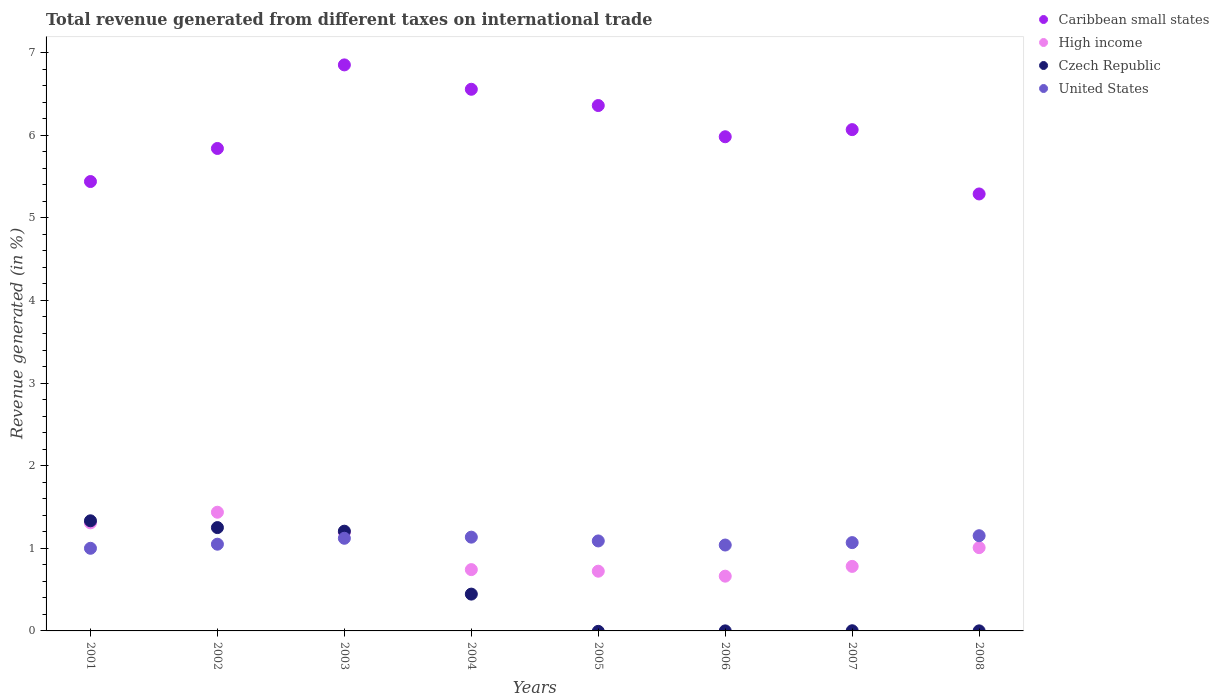Is the number of dotlines equal to the number of legend labels?
Keep it short and to the point. No. What is the total revenue generated in High income in 2004?
Your answer should be compact. 0.74. Across all years, what is the maximum total revenue generated in Caribbean small states?
Ensure brevity in your answer.  6.85. Across all years, what is the minimum total revenue generated in Caribbean small states?
Keep it short and to the point. 5.29. What is the total total revenue generated in High income in the graph?
Offer a very short reply. 7.85. What is the difference between the total revenue generated in United States in 2001 and that in 2005?
Provide a succinct answer. -0.09. What is the difference between the total revenue generated in High income in 2003 and the total revenue generated in United States in 2001?
Your answer should be very brief. 0.19. What is the average total revenue generated in Caribbean small states per year?
Your answer should be very brief. 6.05. In the year 2002, what is the difference between the total revenue generated in United States and total revenue generated in Caribbean small states?
Offer a terse response. -4.79. What is the ratio of the total revenue generated in Caribbean small states in 2001 to that in 2008?
Ensure brevity in your answer.  1.03. Is the difference between the total revenue generated in United States in 2003 and 2006 greater than the difference between the total revenue generated in Caribbean small states in 2003 and 2006?
Give a very brief answer. No. What is the difference between the highest and the second highest total revenue generated in Caribbean small states?
Provide a succinct answer. 0.3. What is the difference between the highest and the lowest total revenue generated in Caribbean small states?
Your response must be concise. 1.56. In how many years, is the total revenue generated in Caribbean small states greater than the average total revenue generated in Caribbean small states taken over all years?
Offer a very short reply. 4. Is the sum of the total revenue generated in United States in 2004 and 2007 greater than the maximum total revenue generated in Caribbean small states across all years?
Your answer should be compact. No. Is it the case that in every year, the sum of the total revenue generated in Caribbean small states and total revenue generated in Czech Republic  is greater than the total revenue generated in United States?
Give a very brief answer. Yes. Does the total revenue generated in Caribbean small states monotonically increase over the years?
Offer a terse response. No. How many years are there in the graph?
Your answer should be very brief. 8. What is the difference between two consecutive major ticks on the Y-axis?
Give a very brief answer. 1. Does the graph contain any zero values?
Offer a terse response. Yes. Does the graph contain grids?
Offer a terse response. No. How many legend labels are there?
Give a very brief answer. 4. What is the title of the graph?
Provide a succinct answer. Total revenue generated from different taxes on international trade. Does "Liberia" appear as one of the legend labels in the graph?
Provide a short and direct response. No. What is the label or title of the Y-axis?
Keep it short and to the point. Revenue generated (in %). What is the Revenue generated (in %) of Caribbean small states in 2001?
Ensure brevity in your answer.  5.44. What is the Revenue generated (in %) of High income in 2001?
Make the answer very short. 1.31. What is the Revenue generated (in %) of Czech Republic in 2001?
Your answer should be very brief. 1.33. What is the Revenue generated (in %) in United States in 2001?
Give a very brief answer. 1. What is the Revenue generated (in %) of Caribbean small states in 2002?
Make the answer very short. 5.84. What is the Revenue generated (in %) in High income in 2002?
Keep it short and to the point. 1.44. What is the Revenue generated (in %) of Czech Republic in 2002?
Keep it short and to the point. 1.25. What is the Revenue generated (in %) in United States in 2002?
Offer a terse response. 1.05. What is the Revenue generated (in %) of Caribbean small states in 2003?
Ensure brevity in your answer.  6.85. What is the Revenue generated (in %) in High income in 2003?
Your answer should be compact. 1.19. What is the Revenue generated (in %) of Czech Republic in 2003?
Give a very brief answer. 1.21. What is the Revenue generated (in %) of United States in 2003?
Provide a succinct answer. 1.12. What is the Revenue generated (in %) in Caribbean small states in 2004?
Your answer should be compact. 6.56. What is the Revenue generated (in %) of High income in 2004?
Give a very brief answer. 0.74. What is the Revenue generated (in %) of Czech Republic in 2004?
Offer a terse response. 0.45. What is the Revenue generated (in %) of United States in 2004?
Provide a succinct answer. 1.13. What is the Revenue generated (in %) of Caribbean small states in 2005?
Make the answer very short. 6.36. What is the Revenue generated (in %) in High income in 2005?
Offer a terse response. 0.72. What is the Revenue generated (in %) of Czech Republic in 2005?
Give a very brief answer. 0. What is the Revenue generated (in %) of United States in 2005?
Ensure brevity in your answer.  1.09. What is the Revenue generated (in %) of Caribbean small states in 2006?
Give a very brief answer. 5.98. What is the Revenue generated (in %) of High income in 2006?
Your response must be concise. 0.66. What is the Revenue generated (in %) in Czech Republic in 2006?
Keep it short and to the point. 0. What is the Revenue generated (in %) in United States in 2006?
Offer a very short reply. 1.04. What is the Revenue generated (in %) of Caribbean small states in 2007?
Offer a terse response. 6.07. What is the Revenue generated (in %) in High income in 2007?
Offer a terse response. 0.78. What is the Revenue generated (in %) in Czech Republic in 2007?
Make the answer very short. 0. What is the Revenue generated (in %) in United States in 2007?
Keep it short and to the point. 1.07. What is the Revenue generated (in %) of Caribbean small states in 2008?
Ensure brevity in your answer.  5.29. What is the Revenue generated (in %) of High income in 2008?
Your answer should be very brief. 1.01. What is the Revenue generated (in %) of Czech Republic in 2008?
Make the answer very short. 0. What is the Revenue generated (in %) of United States in 2008?
Make the answer very short. 1.15. Across all years, what is the maximum Revenue generated (in %) in Caribbean small states?
Your answer should be very brief. 6.85. Across all years, what is the maximum Revenue generated (in %) of High income?
Your answer should be compact. 1.44. Across all years, what is the maximum Revenue generated (in %) of Czech Republic?
Provide a short and direct response. 1.33. Across all years, what is the maximum Revenue generated (in %) in United States?
Your answer should be compact. 1.15. Across all years, what is the minimum Revenue generated (in %) in Caribbean small states?
Give a very brief answer. 5.29. Across all years, what is the minimum Revenue generated (in %) in High income?
Offer a terse response. 0.66. Across all years, what is the minimum Revenue generated (in %) in Czech Republic?
Keep it short and to the point. 0. Across all years, what is the minimum Revenue generated (in %) in United States?
Offer a very short reply. 1. What is the total Revenue generated (in %) of Caribbean small states in the graph?
Your answer should be compact. 48.38. What is the total Revenue generated (in %) in High income in the graph?
Your answer should be compact. 7.85. What is the total Revenue generated (in %) in Czech Republic in the graph?
Your answer should be very brief. 4.24. What is the total Revenue generated (in %) in United States in the graph?
Make the answer very short. 8.66. What is the difference between the Revenue generated (in %) of Caribbean small states in 2001 and that in 2002?
Keep it short and to the point. -0.4. What is the difference between the Revenue generated (in %) of High income in 2001 and that in 2002?
Keep it short and to the point. -0.13. What is the difference between the Revenue generated (in %) in Czech Republic in 2001 and that in 2002?
Your response must be concise. 0.08. What is the difference between the Revenue generated (in %) of United States in 2001 and that in 2002?
Provide a succinct answer. -0.05. What is the difference between the Revenue generated (in %) of Caribbean small states in 2001 and that in 2003?
Your answer should be very brief. -1.41. What is the difference between the Revenue generated (in %) of High income in 2001 and that in 2003?
Your answer should be very brief. 0.11. What is the difference between the Revenue generated (in %) of Czech Republic in 2001 and that in 2003?
Provide a succinct answer. 0.13. What is the difference between the Revenue generated (in %) of United States in 2001 and that in 2003?
Offer a very short reply. -0.12. What is the difference between the Revenue generated (in %) in Caribbean small states in 2001 and that in 2004?
Give a very brief answer. -1.12. What is the difference between the Revenue generated (in %) of High income in 2001 and that in 2004?
Give a very brief answer. 0.57. What is the difference between the Revenue generated (in %) of Czech Republic in 2001 and that in 2004?
Your answer should be compact. 0.89. What is the difference between the Revenue generated (in %) in United States in 2001 and that in 2004?
Your answer should be very brief. -0.13. What is the difference between the Revenue generated (in %) of Caribbean small states in 2001 and that in 2005?
Make the answer very short. -0.92. What is the difference between the Revenue generated (in %) in High income in 2001 and that in 2005?
Your answer should be compact. 0.58. What is the difference between the Revenue generated (in %) in United States in 2001 and that in 2005?
Your response must be concise. -0.09. What is the difference between the Revenue generated (in %) of Caribbean small states in 2001 and that in 2006?
Offer a terse response. -0.54. What is the difference between the Revenue generated (in %) of High income in 2001 and that in 2006?
Your answer should be compact. 0.65. What is the difference between the Revenue generated (in %) of Czech Republic in 2001 and that in 2006?
Keep it short and to the point. 1.33. What is the difference between the Revenue generated (in %) of United States in 2001 and that in 2006?
Provide a short and direct response. -0.04. What is the difference between the Revenue generated (in %) in Caribbean small states in 2001 and that in 2007?
Ensure brevity in your answer.  -0.63. What is the difference between the Revenue generated (in %) in High income in 2001 and that in 2007?
Your answer should be compact. 0.53. What is the difference between the Revenue generated (in %) of Czech Republic in 2001 and that in 2007?
Your answer should be compact. 1.33. What is the difference between the Revenue generated (in %) of United States in 2001 and that in 2007?
Your answer should be compact. -0.07. What is the difference between the Revenue generated (in %) of Caribbean small states in 2001 and that in 2008?
Offer a terse response. 0.15. What is the difference between the Revenue generated (in %) in High income in 2001 and that in 2008?
Ensure brevity in your answer.  0.3. What is the difference between the Revenue generated (in %) in Czech Republic in 2001 and that in 2008?
Make the answer very short. 1.33. What is the difference between the Revenue generated (in %) of United States in 2001 and that in 2008?
Your answer should be very brief. -0.15. What is the difference between the Revenue generated (in %) in Caribbean small states in 2002 and that in 2003?
Offer a very short reply. -1.01. What is the difference between the Revenue generated (in %) in High income in 2002 and that in 2003?
Make the answer very short. 0.24. What is the difference between the Revenue generated (in %) in Czech Republic in 2002 and that in 2003?
Provide a short and direct response. 0.04. What is the difference between the Revenue generated (in %) in United States in 2002 and that in 2003?
Give a very brief answer. -0.07. What is the difference between the Revenue generated (in %) in Caribbean small states in 2002 and that in 2004?
Give a very brief answer. -0.72. What is the difference between the Revenue generated (in %) of High income in 2002 and that in 2004?
Your response must be concise. 0.69. What is the difference between the Revenue generated (in %) in Czech Republic in 2002 and that in 2004?
Ensure brevity in your answer.  0.81. What is the difference between the Revenue generated (in %) in United States in 2002 and that in 2004?
Give a very brief answer. -0.09. What is the difference between the Revenue generated (in %) in Caribbean small states in 2002 and that in 2005?
Keep it short and to the point. -0.52. What is the difference between the Revenue generated (in %) in High income in 2002 and that in 2005?
Your answer should be very brief. 0.71. What is the difference between the Revenue generated (in %) of United States in 2002 and that in 2005?
Provide a succinct answer. -0.04. What is the difference between the Revenue generated (in %) in Caribbean small states in 2002 and that in 2006?
Ensure brevity in your answer.  -0.14. What is the difference between the Revenue generated (in %) in High income in 2002 and that in 2006?
Ensure brevity in your answer.  0.77. What is the difference between the Revenue generated (in %) of Czech Republic in 2002 and that in 2006?
Offer a very short reply. 1.25. What is the difference between the Revenue generated (in %) in United States in 2002 and that in 2006?
Your response must be concise. 0.01. What is the difference between the Revenue generated (in %) in Caribbean small states in 2002 and that in 2007?
Ensure brevity in your answer.  -0.23. What is the difference between the Revenue generated (in %) in High income in 2002 and that in 2007?
Make the answer very short. 0.66. What is the difference between the Revenue generated (in %) in Czech Republic in 2002 and that in 2007?
Your answer should be very brief. 1.25. What is the difference between the Revenue generated (in %) of United States in 2002 and that in 2007?
Give a very brief answer. -0.02. What is the difference between the Revenue generated (in %) in Caribbean small states in 2002 and that in 2008?
Your answer should be compact. 0.55. What is the difference between the Revenue generated (in %) of High income in 2002 and that in 2008?
Ensure brevity in your answer.  0.43. What is the difference between the Revenue generated (in %) in Czech Republic in 2002 and that in 2008?
Your answer should be very brief. 1.25. What is the difference between the Revenue generated (in %) in United States in 2002 and that in 2008?
Your answer should be very brief. -0.1. What is the difference between the Revenue generated (in %) of Caribbean small states in 2003 and that in 2004?
Offer a very short reply. 0.3. What is the difference between the Revenue generated (in %) in High income in 2003 and that in 2004?
Keep it short and to the point. 0.45. What is the difference between the Revenue generated (in %) in Czech Republic in 2003 and that in 2004?
Offer a terse response. 0.76. What is the difference between the Revenue generated (in %) in United States in 2003 and that in 2004?
Your answer should be very brief. -0.01. What is the difference between the Revenue generated (in %) of Caribbean small states in 2003 and that in 2005?
Your answer should be very brief. 0.49. What is the difference between the Revenue generated (in %) of High income in 2003 and that in 2005?
Provide a short and direct response. 0.47. What is the difference between the Revenue generated (in %) in United States in 2003 and that in 2005?
Give a very brief answer. 0.03. What is the difference between the Revenue generated (in %) in Caribbean small states in 2003 and that in 2006?
Your response must be concise. 0.87. What is the difference between the Revenue generated (in %) of High income in 2003 and that in 2006?
Provide a succinct answer. 0.53. What is the difference between the Revenue generated (in %) in Czech Republic in 2003 and that in 2006?
Your answer should be compact. 1.21. What is the difference between the Revenue generated (in %) in United States in 2003 and that in 2006?
Give a very brief answer. 0.08. What is the difference between the Revenue generated (in %) in Caribbean small states in 2003 and that in 2007?
Provide a succinct answer. 0.78. What is the difference between the Revenue generated (in %) in High income in 2003 and that in 2007?
Provide a short and direct response. 0.41. What is the difference between the Revenue generated (in %) of Czech Republic in 2003 and that in 2007?
Keep it short and to the point. 1.21. What is the difference between the Revenue generated (in %) in United States in 2003 and that in 2007?
Provide a succinct answer. 0.05. What is the difference between the Revenue generated (in %) in Caribbean small states in 2003 and that in 2008?
Offer a terse response. 1.56. What is the difference between the Revenue generated (in %) in High income in 2003 and that in 2008?
Provide a short and direct response. 0.19. What is the difference between the Revenue generated (in %) in Czech Republic in 2003 and that in 2008?
Make the answer very short. 1.21. What is the difference between the Revenue generated (in %) of United States in 2003 and that in 2008?
Give a very brief answer. -0.03. What is the difference between the Revenue generated (in %) in Caribbean small states in 2004 and that in 2005?
Offer a very short reply. 0.2. What is the difference between the Revenue generated (in %) in High income in 2004 and that in 2005?
Offer a terse response. 0.02. What is the difference between the Revenue generated (in %) of United States in 2004 and that in 2005?
Give a very brief answer. 0.05. What is the difference between the Revenue generated (in %) of Caribbean small states in 2004 and that in 2006?
Provide a succinct answer. 0.57. What is the difference between the Revenue generated (in %) of High income in 2004 and that in 2006?
Your response must be concise. 0.08. What is the difference between the Revenue generated (in %) of Czech Republic in 2004 and that in 2006?
Ensure brevity in your answer.  0.44. What is the difference between the Revenue generated (in %) in United States in 2004 and that in 2006?
Ensure brevity in your answer.  0.1. What is the difference between the Revenue generated (in %) in Caribbean small states in 2004 and that in 2007?
Keep it short and to the point. 0.49. What is the difference between the Revenue generated (in %) of High income in 2004 and that in 2007?
Provide a short and direct response. -0.04. What is the difference between the Revenue generated (in %) of Czech Republic in 2004 and that in 2007?
Your answer should be compact. 0.44. What is the difference between the Revenue generated (in %) of United States in 2004 and that in 2007?
Provide a short and direct response. 0.07. What is the difference between the Revenue generated (in %) of Caribbean small states in 2004 and that in 2008?
Give a very brief answer. 1.27. What is the difference between the Revenue generated (in %) in High income in 2004 and that in 2008?
Give a very brief answer. -0.27. What is the difference between the Revenue generated (in %) in Czech Republic in 2004 and that in 2008?
Make the answer very short. 0.44. What is the difference between the Revenue generated (in %) in United States in 2004 and that in 2008?
Provide a succinct answer. -0.02. What is the difference between the Revenue generated (in %) in Caribbean small states in 2005 and that in 2006?
Your response must be concise. 0.38. What is the difference between the Revenue generated (in %) in High income in 2005 and that in 2006?
Give a very brief answer. 0.06. What is the difference between the Revenue generated (in %) in United States in 2005 and that in 2006?
Offer a terse response. 0.05. What is the difference between the Revenue generated (in %) of Caribbean small states in 2005 and that in 2007?
Keep it short and to the point. 0.29. What is the difference between the Revenue generated (in %) in High income in 2005 and that in 2007?
Provide a short and direct response. -0.06. What is the difference between the Revenue generated (in %) in United States in 2005 and that in 2007?
Provide a short and direct response. 0.02. What is the difference between the Revenue generated (in %) of Caribbean small states in 2005 and that in 2008?
Your response must be concise. 1.07. What is the difference between the Revenue generated (in %) of High income in 2005 and that in 2008?
Your answer should be very brief. -0.29. What is the difference between the Revenue generated (in %) of United States in 2005 and that in 2008?
Provide a short and direct response. -0.06. What is the difference between the Revenue generated (in %) of Caribbean small states in 2006 and that in 2007?
Your response must be concise. -0.09. What is the difference between the Revenue generated (in %) of High income in 2006 and that in 2007?
Make the answer very short. -0.12. What is the difference between the Revenue generated (in %) of Czech Republic in 2006 and that in 2007?
Your response must be concise. -0. What is the difference between the Revenue generated (in %) in United States in 2006 and that in 2007?
Keep it short and to the point. -0.03. What is the difference between the Revenue generated (in %) in Caribbean small states in 2006 and that in 2008?
Give a very brief answer. 0.69. What is the difference between the Revenue generated (in %) in High income in 2006 and that in 2008?
Give a very brief answer. -0.35. What is the difference between the Revenue generated (in %) of Czech Republic in 2006 and that in 2008?
Ensure brevity in your answer.  -0. What is the difference between the Revenue generated (in %) in United States in 2006 and that in 2008?
Make the answer very short. -0.11. What is the difference between the Revenue generated (in %) in Caribbean small states in 2007 and that in 2008?
Your answer should be compact. 0.78. What is the difference between the Revenue generated (in %) in High income in 2007 and that in 2008?
Offer a terse response. -0.23. What is the difference between the Revenue generated (in %) in Czech Republic in 2007 and that in 2008?
Your response must be concise. 0. What is the difference between the Revenue generated (in %) in United States in 2007 and that in 2008?
Give a very brief answer. -0.08. What is the difference between the Revenue generated (in %) in Caribbean small states in 2001 and the Revenue generated (in %) in High income in 2002?
Provide a short and direct response. 4. What is the difference between the Revenue generated (in %) of Caribbean small states in 2001 and the Revenue generated (in %) of Czech Republic in 2002?
Your answer should be very brief. 4.19. What is the difference between the Revenue generated (in %) of Caribbean small states in 2001 and the Revenue generated (in %) of United States in 2002?
Give a very brief answer. 4.39. What is the difference between the Revenue generated (in %) in High income in 2001 and the Revenue generated (in %) in Czech Republic in 2002?
Your answer should be compact. 0.06. What is the difference between the Revenue generated (in %) in High income in 2001 and the Revenue generated (in %) in United States in 2002?
Keep it short and to the point. 0.26. What is the difference between the Revenue generated (in %) of Czech Republic in 2001 and the Revenue generated (in %) of United States in 2002?
Your answer should be compact. 0.28. What is the difference between the Revenue generated (in %) of Caribbean small states in 2001 and the Revenue generated (in %) of High income in 2003?
Provide a succinct answer. 4.25. What is the difference between the Revenue generated (in %) in Caribbean small states in 2001 and the Revenue generated (in %) in Czech Republic in 2003?
Your response must be concise. 4.23. What is the difference between the Revenue generated (in %) in Caribbean small states in 2001 and the Revenue generated (in %) in United States in 2003?
Give a very brief answer. 4.32. What is the difference between the Revenue generated (in %) in High income in 2001 and the Revenue generated (in %) in Czech Republic in 2003?
Keep it short and to the point. 0.1. What is the difference between the Revenue generated (in %) of High income in 2001 and the Revenue generated (in %) of United States in 2003?
Give a very brief answer. 0.19. What is the difference between the Revenue generated (in %) in Czech Republic in 2001 and the Revenue generated (in %) in United States in 2003?
Provide a short and direct response. 0.21. What is the difference between the Revenue generated (in %) of Caribbean small states in 2001 and the Revenue generated (in %) of High income in 2004?
Your response must be concise. 4.7. What is the difference between the Revenue generated (in %) in Caribbean small states in 2001 and the Revenue generated (in %) in Czech Republic in 2004?
Your response must be concise. 4.99. What is the difference between the Revenue generated (in %) of Caribbean small states in 2001 and the Revenue generated (in %) of United States in 2004?
Give a very brief answer. 4.3. What is the difference between the Revenue generated (in %) in High income in 2001 and the Revenue generated (in %) in Czech Republic in 2004?
Your answer should be compact. 0.86. What is the difference between the Revenue generated (in %) in High income in 2001 and the Revenue generated (in %) in United States in 2004?
Your answer should be very brief. 0.17. What is the difference between the Revenue generated (in %) of Czech Republic in 2001 and the Revenue generated (in %) of United States in 2004?
Offer a very short reply. 0.2. What is the difference between the Revenue generated (in %) of Caribbean small states in 2001 and the Revenue generated (in %) of High income in 2005?
Provide a succinct answer. 4.72. What is the difference between the Revenue generated (in %) in Caribbean small states in 2001 and the Revenue generated (in %) in United States in 2005?
Ensure brevity in your answer.  4.35. What is the difference between the Revenue generated (in %) of High income in 2001 and the Revenue generated (in %) of United States in 2005?
Keep it short and to the point. 0.22. What is the difference between the Revenue generated (in %) of Czech Republic in 2001 and the Revenue generated (in %) of United States in 2005?
Provide a short and direct response. 0.24. What is the difference between the Revenue generated (in %) of Caribbean small states in 2001 and the Revenue generated (in %) of High income in 2006?
Your answer should be very brief. 4.78. What is the difference between the Revenue generated (in %) in Caribbean small states in 2001 and the Revenue generated (in %) in Czech Republic in 2006?
Your answer should be very brief. 5.44. What is the difference between the Revenue generated (in %) of Caribbean small states in 2001 and the Revenue generated (in %) of United States in 2006?
Your response must be concise. 4.4. What is the difference between the Revenue generated (in %) of High income in 2001 and the Revenue generated (in %) of Czech Republic in 2006?
Your response must be concise. 1.31. What is the difference between the Revenue generated (in %) in High income in 2001 and the Revenue generated (in %) in United States in 2006?
Keep it short and to the point. 0.27. What is the difference between the Revenue generated (in %) in Czech Republic in 2001 and the Revenue generated (in %) in United States in 2006?
Provide a short and direct response. 0.29. What is the difference between the Revenue generated (in %) in Caribbean small states in 2001 and the Revenue generated (in %) in High income in 2007?
Make the answer very short. 4.66. What is the difference between the Revenue generated (in %) of Caribbean small states in 2001 and the Revenue generated (in %) of Czech Republic in 2007?
Keep it short and to the point. 5.44. What is the difference between the Revenue generated (in %) of Caribbean small states in 2001 and the Revenue generated (in %) of United States in 2007?
Offer a very short reply. 4.37. What is the difference between the Revenue generated (in %) of High income in 2001 and the Revenue generated (in %) of Czech Republic in 2007?
Provide a succinct answer. 1.31. What is the difference between the Revenue generated (in %) in High income in 2001 and the Revenue generated (in %) in United States in 2007?
Provide a succinct answer. 0.24. What is the difference between the Revenue generated (in %) of Czech Republic in 2001 and the Revenue generated (in %) of United States in 2007?
Make the answer very short. 0.26. What is the difference between the Revenue generated (in %) in Caribbean small states in 2001 and the Revenue generated (in %) in High income in 2008?
Offer a very short reply. 4.43. What is the difference between the Revenue generated (in %) of Caribbean small states in 2001 and the Revenue generated (in %) of Czech Republic in 2008?
Keep it short and to the point. 5.44. What is the difference between the Revenue generated (in %) of Caribbean small states in 2001 and the Revenue generated (in %) of United States in 2008?
Provide a short and direct response. 4.29. What is the difference between the Revenue generated (in %) of High income in 2001 and the Revenue generated (in %) of Czech Republic in 2008?
Keep it short and to the point. 1.31. What is the difference between the Revenue generated (in %) of High income in 2001 and the Revenue generated (in %) of United States in 2008?
Provide a succinct answer. 0.16. What is the difference between the Revenue generated (in %) in Czech Republic in 2001 and the Revenue generated (in %) in United States in 2008?
Provide a succinct answer. 0.18. What is the difference between the Revenue generated (in %) in Caribbean small states in 2002 and the Revenue generated (in %) in High income in 2003?
Your answer should be very brief. 4.65. What is the difference between the Revenue generated (in %) of Caribbean small states in 2002 and the Revenue generated (in %) of Czech Republic in 2003?
Make the answer very short. 4.63. What is the difference between the Revenue generated (in %) in Caribbean small states in 2002 and the Revenue generated (in %) in United States in 2003?
Keep it short and to the point. 4.72. What is the difference between the Revenue generated (in %) of High income in 2002 and the Revenue generated (in %) of Czech Republic in 2003?
Provide a short and direct response. 0.23. What is the difference between the Revenue generated (in %) in High income in 2002 and the Revenue generated (in %) in United States in 2003?
Your answer should be very brief. 0.32. What is the difference between the Revenue generated (in %) in Czech Republic in 2002 and the Revenue generated (in %) in United States in 2003?
Ensure brevity in your answer.  0.13. What is the difference between the Revenue generated (in %) of Caribbean small states in 2002 and the Revenue generated (in %) of High income in 2004?
Offer a very short reply. 5.1. What is the difference between the Revenue generated (in %) of Caribbean small states in 2002 and the Revenue generated (in %) of Czech Republic in 2004?
Give a very brief answer. 5.39. What is the difference between the Revenue generated (in %) in Caribbean small states in 2002 and the Revenue generated (in %) in United States in 2004?
Give a very brief answer. 4.7. What is the difference between the Revenue generated (in %) of High income in 2002 and the Revenue generated (in %) of Czech Republic in 2004?
Make the answer very short. 0.99. What is the difference between the Revenue generated (in %) of High income in 2002 and the Revenue generated (in %) of United States in 2004?
Provide a succinct answer. 0.3. What is the difference between the Revenue generated (in %) in Czech Republic in 2002 and the Revenue generated (in %) in United States in 2004?
Keep it short and to the point. 0.12. What is the difference between the Revenue generated (in %) of Caribbean small states in 2002 and the Revenue generated (in %) of High income in 2005?
Provide a short and direct response. 5.12. What is the difference between the Revenue generated (in %) of Caribbean small states in 2002 and the Revenue generated (in %) of United States in 2005?
Your answer should be very brief. 4.75. What is the difference between the Revenue generated (in %) in High income in 2002 and the Revenue generated (in %) in United States in 2005?
Keep it short and to the point. 0.35. What is the difference between the Revenue generated (in %) in Czech Republic in 2002 and the Revenue generated (in %) in United States in 2005?
Keep it short and to the point. 0.16. What is the difference between the Revenue generated (in %) of Caribbean small states in 2002 and the Revenue generated (in %) of High income in 2006?
Provide a short and direct response. 5.18. What is the difference between the Revenue generated (in %) of Caribbean small states in 2002 and the Revenue generated (in %) of Czech Republic in 2006?
Offer a very short reply. 5.84. What is the difference between the Revenue generated (in %) of Caribbean small states in 2002 and the Revenue generated (in %) of United States in 2006?
Ensure brevity in your answer.  4.8. What is the difference between the Revenue generated (in %) of High income in 2002 and the Revenue generated (in %) of Czech Republic in 2006?
Provide a short and direct response. 1.44. What is the difference between the Revenue generated (in %) in High income in 2002 and the Revenue generated (in %) in United States in 2006?
Give a very brief answer. 0.4. What is the difference between the Revenue generated (in %) in Czech Republic in 2002 and the Revenue generated (in %) in United States in 2006?
Your answer should be very brief. 0.21. What is the difference between the Revenue generated (in %) of Caribbean small states in 2002 and the Revenue generated (in %) of High income in 2007?
Ensure brevity in your answer.  5.06. What is the difference between the Revenue generated (in %) of Caribbean small states in 2002 and the Revenue generated (in %) of Czech Republic in 2007?
Your answer should be very brief. 5.84. What is the difference between the Revenue generated (in %) of Caribbean small states in 2002 and the Revenue generated (in %) of United States in 2007?
Keep it short and to the point. 4.77. What is the difference between the Revenue generated (in %) in High income in 2002 and the Revenue generated (in %) in Czech Republic in 2007?
Provide a succinct answer. 1.43. What is the difference between the Revenue generated (in %) in High income in 2002 and the Revenue generated (in %) in United States in 2007?
Ensure brevity in your answer.  0.37. What is the difference between the Revenue generated (in %) of Czech Republic in 2002 and the Revenue generated (in %) of United States in 2007?
Keep it short and to the point. 0.18. What is the difference between the Revenue generated (in %) of Caribbean small states in 2002 and the Revenue generated (in %) of High income in 2008?
Offer a terse response. 4.83. What is the difference between the Revenue generated (in %) in Caribbean small states in 2002 and the Revenue generated (in %) in Czech Republic in 2008?
Your answer should be very brief. 5.84. What is the difference between the Revenue generated (in %) in Caribbean small states in 2002 and the Revenue generated (in %) in United States in 2008?
Provide a short and direct response. 4.69. What is the difference between the Revenue generated (in %) of High income in 2002 and the Revenue generated (in %) of Czech Republic in 2008?
Your response must be concise. 1.44. What is the difference between the Revenue generated (in %) in High income in 2002 and the Revenue generated (in %) in United States in 2008?
Ensure brevity in your answer.  0.28. What is the difference between the Revenue generated (in %) in Czech Republic in 2002 and the Revenue generated (in %) in United States in 2008?
Your answer should be very brief. 0.1. What is the difference between the Revenue generated (in %) in Caribbean small states in 2003 and the Revenue generated (in %) in High income in 2004?
Your answer should be very brief. 6.11. What is the difference between the Revenue generated (in %) of Caribbean small states in 2003 and the Revenue generated (in %) of Czech Republic in 2004?
Offer a terse response. 6.41. What is the difference between the Revenue generated (in %) of Caribbean small states in 2003 and the Revenue generated (in %) of United States in 2004?
Provide a succinct answer. 5.72. What is the difference between the Revenue generated (in %) of High income in 2003 and the Revenue generated (in %) of Czech Republic in 2004?
Provide a short and direct response. 0.75. What is the difference between the Revenue generated (in %) of High income in 2003 and the Revenue generated (in %) of United States in 2004?
Offer a very short reply. 0.06. What is the difference between the Revenue generated (in %) of Czech Republic in 2003 and the Revenue generated (in %) of United States in 2004?
Provide a short and direct response. 0.07. What is the difference between the Revenue generated (in %) in Caribbean small states in 2003 and the Revenue generated (in %) in High income in 2005?
Provide a succinct answer. 6.13. What is the difference between the Revenue generated (in %) in Caribbean small states in 2003 and the Revenue generated (in %) in United States in 2005?
Your response must be concise. 5.76. What is the difference between the Revenue generated (in %) in High income in 2003 and the Revenue generated (in %) in United States in 2005?
Give a very brief answer. 0.1. What is the difference between the Revenue generated (in %) of Czech Republic in 2003 and the Revenue generated (in %) of United States in 2005?
Ensure brevity in your answer.  0.12. What is the difference between the Revenue generated (in %) in Caribbean small states in 2003 and the Revenue generated (in %) in High income in 2006?
Make the answer very short. 6.19. What is the difference between the Revenue generated (in %) in Caribbean small states in 2003 and the Revenue generated (in %) in Czech Republic in 2006?
Give a very brief answer. 6.85. What is the difference between the Revenue generated (in %) in Caribbean small states in 2003 and the Revenue generated (in %) in United States in 2006?
Offer a terse response. 5.81. What is the difference between the Revenue generated (in %) of High income in 2003 and the Revenue generated (in %) of Czech Republic in 2006?
Provide a short and direct response. 1.19. What is the difference between the Revenue generated (in %) in High income in 2003 and the Revenue generated (in %) in United States in 2006?
Your answer should be compact. 0.15. What is the difference between the Revenue generated (in %) of Czech Republic in 2003 and the Revenue generated (in %) of United States in 2006?
Keep it short and to the point. 0.17. What is the difference between the Revenue generated (in %) of Caribbean small states in 2003 and the Revenue generated (in %) of High income in 2007?
Your answer should be very brief. 6.07. What is the difference between the Revenue generated (in %) of Caribbean small states in 2003 and the Revenue generated (in %) of Czech Republic in 2007?
Offer a very short reply. 6.85. What is the difference between the Revenue generated (in %) of Caribbean small states in 2003 and the Revenue generated (in %) of United States in 2007?
Your response must be concise. 5.78. What is the difference between the Revenue generated (in %) of High income in 2003 and the Revenue generated (in %) of Czech Republic in 2007?
Your answer should be very brief. 1.19. What is the difference between the Revenue generated (in %) of High income in 2003 and the Revenue generated (in %) of United States in 2007?
Offer a very short reply. 0.12. What is the difference between the Revenue generated (in %) in Czech Republic in 2003 and the Revenue generated (in %) in United States in 2007?
Offer a terse response. 0.14. What is the difference between the Revenue generated (in %) of Caribbean small states in 2003 and the Revenue generated (in %) of High income in 2008?
Ensure brevity in your answer.  5.84. What is the difference between the Revenue generated (in %) in Caribbean small states in 2003 and the Revenue generated (in %) in Czech Republic in 2008?
Give a very brief answer. 6.85. What is the difference between the Revenue generated (in %) in Caribbean small states in 2003 and the Revenue generated (in %) in United States in 2008?
Give a very brief answer. 5.7. What is the difference between the Revenue generated (in %) of High income in 2003 and the Revenue generated (in %) of Czech Republic in 2008?
Your response must be concise. 1.19. What is the difference between the Revenue generated (in %) in High income in 2003 and the Revenue generated (in %) in United States in 2008?
Keep it short and to the point. 0.04. What is the difference between the Revenue generated (in %) of Czech Republic in 2003 and the Revenue generated (in %) of United States in 2008?
Provide a short and direct response. 0.05. What is the difference between the Revenue generated (in %) in Caribbean small states in 2004 and the Revenue generated (in %) in High income in 2005?
Offer a terse response. 5.83. What is the difference between the Revenue generated (in %) of Caribbean small states in 2004 and the Revenue generated (in %) of United States in 2005?
Provide a short and direct response. 5.47. What is the difference between the Revenue generated (in %) of High income in 2004 and the Revenue generated (in %) of United States in 2005?
Make the answer very short. -0.35. What is the difference between the Revenue generated (in %) of Czech Republic in 2004 and the Revenue generated (in %) of United States in 2005?
Give a very brief answer. -0.64. What is the difference between the Revenue generated (in %) of Caribbean small states in 2004 and the Revenue generated (in %) of High income in 2006?
Offer a terse response. 5.89. What is the difference between the Revenue generated (in %) in Caribbean small states in 2004 and the Revenue generated (in %) in Czech Republic in 2006?
Offer a terse response. 6.55. What is the difference between the Revenue generated (in %) of Caribbean small states in 2004 and the Revenue generated (in %) of United States in 2006?
Provide a succinct answer. 5.52. What is the difference between the Revenue generated (in %) in High income in 2004 and the Revenue generated (in %) in Czech Republic in 2006?
Keep it short and to the point. 0.74. What is the difference between the Revenue generated (in %) of High income in 2004 and the Revenue generated (in %) of United States in 2006?
Provide a succinct answer. -0.3. What is the difference between the Revenue generated (in %) of Czech Republic in 2004 and the Revenue generated (in %) of United States in 2006?
Offer a very short reply. -0.59. What is the difference between the Revenue generated (in %) of Caribbean small states in 2004 and the Revenue generated (in %) of High income in 2007?
Your answer should be very brief. 5.77. What is the difference between the Revenue generated (in %) of Caribbean small states in 2004 and the Revenue generated (in %) of Czech Republic in 2007?
Provide a short and direct response. 6.55. What is the difference between the Revenue generated (in %) in Caribbean small states in 2004 and the Revenue generated (in %) in United States in 2007?
Ensure brevity in your answer.  5.49. What is the difference between the Revenue generated (in %) in High income in 2004 and the Revenue generated (in %) in Czech Republic in 2007?
Provide a succinct answer. 0.74. What is the difference between the Revenue generated (in %) of High income in 2004 and the Revenue generated (in %) of United States in 2007?
Keep it short and to the point. -0.33. What is the difference between the Revenue generated (in %) in Czech Republic in 2004 and the Revenue generated (in %) in United States in 2007?
Give a very brief answer. -0.62. What is the difference between the Revenue generated (in %) in Caribbean small states in 2004 and the Revenue generated (in %) in High income in 2008?
Ensure brevity in your answer.  5.55. What is the difference between the Revenue generated (in %) in Caribbean small states in 2004 and the Revenue generated (in %) in Czech Republic in 2008?
Offer a terse response. 6.55. What is the difference between the Revenue generated (in %) of Caribbean small states in 2004 and the Revenue generated (in %) of United States in 2008?
Your response must be concise. 5.4. What is the difference between the Revenue generated (in %) of High income in 2004 and the Revenue generated (in %) of Czech Republic in 2008?
Offer a terse response. 0.74. What is the difference between the Revenue generated (in %) in High income in 2004 and the Revenue generated (in %) in United States in 2008?
Offer a very short reply. -0.41. What is the difference between the Revenue generated (in %) in Czech Republic in 2004 and the Revenue generated (in %) in United States in 2008?
Keep it short and to the point. -0.71. What is the difference between the Revenue generated (in %) in Caribbean small states in 2005 and the Revenue generated (in %) in High income in 2006?
Offer a terse response. 5.7. What is the difference between the Revenue generated (in %) in Caribbean small states in 2005 and the Revenue generated (in %) in Czech Republic in 2006?
Your response must be concise. 6.36. What is the difference between the Revenue generated (in %) in Caribbean small states in 2005 and the Revenue generated (in %) in United States in 2006?
Provide a succinct answer. 5.32. What is the difference between the Revenue generated (in %) in High income in 2005 and the Revenue generated (in %) in Czech Republic in 2006?
Your response must be concise. 0.72. What is the difference between the Revenue generated (in %) of High income in 2005 and the Revenue generated (in %) of United States in 2006?
Your response must be concise. -0.32. What is the difference between the Revenue generated (in %) of Caribbean small states in 2005 and the Revenue generated (in %) of High income in 2007?
Ensure brevity in your answer.  5.58. What is the difference between the Revenue generated (in %) in Caribbean small states in 2005 and the Revenue generated (in %) in Czech Republic in 2007?
Your answer should be very brief. 6.36. What is the difference between the Revenue generated (in %) in Caribbean small states in 2005 and the Revenue generated (in %) in United States in 2007?
Provide a succinct answer. 5.29. What is the difference between the Revenue generated (in %) of High income in 2005 and the Revenue generated (in %) of Czech Republic in 2007?
Provide a short and direct response. 0.72. What is the difference between the Revenue generated (in %) in High income in 2005 and the Revenue generated (in %) in United States in 2007?
Provide a succinct answer. -0.35. What is the difference between the Revenue generated (in %) of Caribbean small states in 2005 and the Revenue generated (in %) of High income in 2008?
Your answer should be very brief. 5.35. What is the difference between the Revenue generated (in %) of Caribbean small states in 2005 and the Revenue generated (in %) of Czech Republic in 2008?
Your response must be concise. 6.36. What is the difference between the Revenue generated (in %) in Caribbean small states in 2005 and the Revenue generated (in %) in United States in 2008?
Provide a short and direct response. 5.21. What is the difference between the Revenue generated (in %) in High income in 2005 and the Revenue generated (in %) in Czech Republic in 2008?
Provide a short and direct response. 0.72. What is the difference between the Revenue generated (in %) of High income in 2005 and the Revenue generated (in %) of United States in 2008?
Offer a terse response. -0.43. What is the difference between the Revenue generated (in %) in Caribbean small states in 2006 and the Revenue generated (in %) in High income in 2007?
Offer a terse response. 5.2. What is the difference between the Revenue generated (in %) in Caribbean small states in 2006 and the Revenue generated (in %) in Czech Republic in 2007?
Provide a short and direct response. 5.98. What is the difference between the Revenue generated (in %) in Caribbean small states in 2006 and the Revenue generated (in %) in United States in 2007?
Your answer should be compact. 4.91. What is the difference between the Revenue generated (in %) in High income in 2006 and the Revenue generated (in %) in Czech Republic in 2007?
Provide a succinct answer. 0.66. What is the difference between the Revenue generated (in %) of High income in 2006 and the Revenue generated (in %) of United States in 2007?
Give a very brief answer. -0.41. What is the difference between the Revenue generated (in %) in Czech Republic in 2006 and the Revenue generated (in %) in United States in 2007?
Keep it short and to the point. -1.07. What is the difference between the Revenue generated (in %) in Caribbean small states in 2006 and the Revenue generated (in %) in High income in 2008?
Offer a very short reply. 4.97. What is the difference between the Revenue generated (in %) in Caribbean small states in 2006 and the Revenue generated (in %) in Czech Republic in 2008?
Your response must be concise. 5.98. What is the difference between the Revenue generated (in %) in Caribbean small states in 2006 and the Revenue generated (in %) in United States in 2008?
Keep it short and to the point. 4.83. What is the difference between the Revenue generated (in %) in High income in 2006 and the Revenue generated (in %) in Czech Republic in 2008?
Ensure brevity in your answer.  0.66. What is the difference between the Revenue generated (in %) in High income in 2006 and the Revenue generated (in %) in United States in 2008?
Your answer should be very brief. -0.49. What is the difference between the Revenue generated (in %) in Czech Republic in 2006 and the Revenue generated (in %) in United States in 2008?
Your answer should be very brief. -1.15. What is the difference between the Revenue generated (in %) in Caribbean small states in 2007 and the Revenue generated (in %) in High income in 2008?
Provide a short and direct response. 5.06. What is the difference between the Revenue generated (in %) of Caribbean small states in 2007 and the Revenue generated (in %) of Czech Republic in 2008?
Offer a terse response. 6.07. What is the difference between the Revenue generated (in %) of Caribbean small states in 2007 and the Revenue generated (in %) of United States in 2008?
Your answer should be compact. 4.92. What is the difference between the Revenue generated (in %) of High income in 2007 and the Revenue generated (in %) of Czech Republic in 2008?
Your answer should be very brief. 0.78. What is the difference between the Revenue generated (in %) of High income in 2007 and the Revenue generated (in %) of United States in 2008?
Make the answer very short. -0.37. What is the difference between the Revenue generated (in %) of Czech Republic in 2007 and the Revenue generated (in %) of United States in 2008?
Offer a very short reply. -1.15. What is the average Revenue generated (in %) of Caribbean small states per year?
Provide a short and direct response. 6.05. What is the average Revenue generated (in %) in High income per year?
Make the answer very short. 0.98. What is the average Revenue generated (in %) in Czech Republic per year?
Your answer should be compact. 0.53. What is the average Revenue generated (in %) of United States per year?
Offer a very short reply. 1.08. In the year 2001, what is the difference between the Revenue generated (in %) of Caribbean small states and Revenue generated (in %) of High income?
Your answer should be very brief. 4.13. In the year 2001, what is the difference between the Revenue generated (in %) in Caribbean small states and Revenue generated (in %) in Czech Republic?
Provide a short and direct response. 4.11. In the year 2001, what is the difference between the Revenue generated (in %) in Caribbean small states and Revenue generated (in %) in United States?
Provide a succinct answer. 4.44. In the year 2001, what is the difference between the Revenue generated (in %) of High income and Revenue generated (in %) of Czech Republic?
Offer a very short reply. -0.02. In the year 2001, what is the difference between the Revenue generated (in %) in High income and Revenue generated (in %) in United States?
Ensure brevity in your answer.  0.31. In the year 2001, what is the difference between the Revenue generated (in %) in Czech Republic and Revenue generated (in %) in United States?
Make the answer very short. 0.33. In the year 2002, what is the difference between the Revenue generated (in %) in Caribbean small states and Revenue generated (in %) in High income?
Keep it short and to the point. 4.4. In the year 2002, what is the difference between the Revenue generated (in %) in Caribbean small states and Revenue generated (in %) in Czech Republic?
Give a very brief answer. 4.59. In the year 2002, what is the difference between the Revenue generated (in %) of Caribbean small states and Revenue generated (in %) of United States?
Give a very brief answer. 4.79. In the year 2002, what is the difference between the Revenue generated (in %) of High income and Revenue generated (in %) of Czech Republic?
Provide a succinct answer. 0.19. In the year 2002, what is the difference between the Revenue generated (in %) in High income and Revenue generated (in %) in United States?
Your answer should be compact. 0.39. In the year 2002, what is the difference between the Revenue generated (in %) of Czech Republic and Revenue generated (in %) of United States?
Offer a terse response. 0.2. In the year 2003, what is the difference between the Revenue generated (in %) in Caribbean small states and Revenue generated (in %) in High income?
Provide a short and direct response. 5.66. In the year 2003, what is the difference between the Revenue generated (in %) in Caribbean small states and Revenue generated (in %) in Czech Republic?
Your response must be concise. 5.64. In the year 2003, what is the difference between the Revenue generated (in %) in Caribbean small states and Revenue generated (in %) in United States?
Offer a terse response. 5.73. In the year 2003, what is the difference between the Revenue generated (in %) in High income and Revenue generated (in %) in Czech Republic?
Provide a succinct answer. -0.01. In the year 2003, what is the difference between the Revenue generated (in %) of High income and Revenue generated (in %) of United States?
Keep it short and to the point. 0.07. In the year 2003, what is the difference between the Revenue generated (in %) in Czech Republic and Revenue generated (in %) in United States?
Provide a succinct answer. 0.09. In the year 2004, what is the difference between the Revenue generated (in %) of Caribbean small states and Revenue generated (in %) of High income?
Your answer should be very brief. 5.81. In the year 2004, what is the difference between the Revenue generated (in %) in Caribbean small states and Revenue generated (in %) in Czech Republic?
Offer a terse response. 6.11. In the year 2004, what is the difference between the Revenue generated (in %) of Caribbean small states and Revenue generated (in %) of United States?
Offer a terse response. 5.42. In the year 2004, what is the difference between the Revenue generated (in %) of High income and Revenue generated (in %) of Czech Republic?
Keep it short and to the point. 0.3. In the year 2004, what is the difference between the Revenue generated (in %) in High income and Revenue generated (in %) in United States?
Offer a very short reply. -0.39. In the year 2004, what is the difference between the Revenue generated (in %) in Czech Republic and Revenue generated (in %) in United States?
Ensure brevity in your answer.  -0.69. In the year 2005, what is the difference between the Revenue generated (in %) of Caribbean small states and Revenue generated (in %) of High income?
Ensure brevity in your answer.  5.64. In the year 2005, what is the difference between the Revenue generated (in %) of Caribbean small states and Revenue generated (in %) of United States?
Offer a terse response. 5.27. In the year 2005, what is the difference between the Revenue generated (in %) of High income and Revenue generated (in %) of United States?
Ensure brevity in your answer.  -0.37. In the year 2006, what is the difference between the Revenue generated (in %) in Caribbean small states and Revenue generated (in %) in High income?
Offer a very short reply. 5.32. In the year 2006, what is the difference between the Revenue generated (in %) in Caribbean small states and Revenue generated (in %) in Czech Republic?
Offer a very short reply. 5.98. In the year 2006, what is the difference between the Revenue generated (in %) of Caribbean small states and Revenue generated (in %) of United States?
Provide a short and direct response. 4.94. In the year 2006, what is the difference between the Revenue generated (in %) in High income and Revenue generated (in %) in Czech Republic?
Give a very brief answer. 0.66. In the year 2006, what is the difference between the Revenue generated (in %) in High income and Revenue generated (in %) in United States?
Make the answer very short. -0.38. In the year 2006, what is the difference between the Revenue generated (in %) in Czech Republic and Revenue generated (in %) in United States?
Your answer should be very brief. -1.04. In the year 2007, what is the difference between the Revenue generated (in %) of Caribbean small states and Revenue generated (in %) of High income?
Offer a terse response. 5.29. In the year 2007, what is the difference between the Revenue generated (in %) in Caribbean small states and Revenue generated (in %) in Czech Republic?
Offer a terse response. 6.07. In the year 2007, what is the difference between the Revenue generated (in %) of Caribbean small states and Revenue generated (in %) of United States?
Provide a short and direct response. 5. In the year 2007, what is the difference between the Revenue generated (in %) in High income and Revenue generated (in %) in Czech Republic?
Provide a short and direct response. 0.78. In the year 2007, what is the difference between the Revenue generated (in %) in High income and Revenue generated (in %) in United States?
Offer a terse response. -0.29. In the year 2007, what is the difference between the Revenue generated (in %) of Czech Republic and Revenue generated (in %) of United States?
Provide a succinct answer. -1.07. In the year 2008, what is the difference between the Revenue generated (in %) in Caribbean small states and Revenue generated (in %) in High income?
Your answer should be compact. 4.28. In the year 2008, what is the difference between the Revenue generated (in %) of Caribbean small states and Revenue generated (in %) of Czech Republic?
Provide a short and direct response. 5.29. In the year 2008, what is the difference between the Revenue generated (in %) in Caribbean small states and Revenue generated (in %) in United States?
Make the answer very short. 4.14. In the year 2008, what is the difference between the Revenue generated (in %) of High income and Revenue generated (in %) of Czech Republic?
Your answer should be very brief. 1.01. In the year 2008, what is the difference between the Revenue generated (in %) in High income and Revenue generated (in %) in United States?
Keep it short and to the point. -0.14. In the year 2008, what is the difference between the Revenue generated (in %) of Czech Republic and Revenue generated (in %) of United States?
Your answer should be compact. -1.15. What is the ratio of the Revenue generated (in %) of Caribbean small states in 2001 to that in 2002?
Your response must be concise. 0.93. What is the ratio of the Revenue generated (in %) of High income in 2001 to that in 2002?
Make the answer very short. 0.91. What is the ratio of the Revenue generated (in %) of Czech Republic in 2001 to that in 2002?
Give a very brief answer. 1.07. What is the ratio of the Revenue generated (in %) in United States in 2001 to that in 2002?
Your answer should be compact. 0.95. What is the ratio of the Revenue generated (in %) in Caribbean small states in 2001 to that in 2003?
Offer a very short reply. 0.79. What is the ratio of the Revenue generated (in %) in High income in 2001 to that in 2003?
Your answer should be very brief. 1.1. What is the ratio of the Revenue generated (in %) in Czech Republic in 2001 to that in 2003?
Your response must be concise. 1.1. What is the ratio of the Revenue generated (in %) of United States in 2001 to that in 2003?
Keep it short and to the point. 0.89. What is the ratio of the Revenue generated (in %) in Caribbean small states in 2001 to that in 2004?
Offer a terse response. 0.83. What is the ratio of the Revenue generated (in %) in High income in 2001 to that in 2004?
Provide a short and direct response. 1.76. What is the ratio of the Revenue generated (in %) in Czech Republic in 2001 to that in 2004?
Offer a very short reply. 2.99. What is the ratio of the Revenue generated (in %) of United States in 2001 to that in 2004?
Provide a succinct answer. 0.88. What is the ratio of the Revenue generated (in %) of Caribbean small states in 2001 to that in 2005?
Give a very brief answer. 0.86. What is the ratio of the Revenue generated (in %) of High income in 2001 to that in 2005?
Make the answer very short. 1.81. What is the ratio of the Revenue generated (in %) of United States in 2001 to that in 2005?
Ensure brevity in your answer.  0.92. What is the ratio of the Revenue generated (in %) in Caribbean small states in 2001 to that in 2006?
Offer a terse response. 0.91. What is the ratio of the Revenue generated (in %) in High income in 2001 to that in 2006?
Ensure brevity in your answer.  1.97. What is the ratio of the Revenue generated (in %) of Czech Republic in 2001 to that in 2006?
Provide a short and direct response. 2283.11. What is the ratio of the Revenue generated (in %) in United States in 2001 to that in 2006?
Your response must be concise. 0.96. What is the ratio of the Revenue generated (in %) of Caribbean small states in 2001 to that in 2007?
Your response must be concise. 0.9. What is the ratio of the Revenue generated (in %) in High income in 2001 to that in 2007?
Provide a succinct answer. 1.67. What is the ratio of the Revenue generated (in %) of Czech Republic in 2001 to that in 2007?
Offer a very short reply. 641.71. What is the ratio of the Revenue generated (in %) in United States in 2001 to that in 2007?
Your answer should be compact. 0.94. What is the ratio of the Revenue generated (in %) in Caribbean small states in 2001 to that in 2008?
Ensure brevity in your answer.  1.03. What is the ratio of the Revenue generated (in %) of High income in 2001 to that in 2008?
Provide a succinct answer. 1.3. What is the ratio of the Revenue generated (in %) in Czech Republic in 2001 to that in 2008?
Offer a very short reply. 2033.64. What is the ratio of the Revenue generated (in %) of United States in 2001 to that in 2008?
Give a very brief answer. 0.87. What is the ratio of the Revenue generated (in %) of Caribbean small states in 2002 to that in 2003?
Provide a short and direct response. 0.85. What is the ratio of the Revenue generated (in %) of High income in 2002 to that in 2003?
Offer a very short reply. 1.2. What is the ratio of the Revenue generated (in %) of Czech Republic in 2002 to that in 2003?
Give a very brief answer. 1.04. What is the ratio of the Revenue generated (in %) in United States in 2002 to that in 2003?
Your answer should be very brief. 0.94. What is the ratio of the Revenue generated (in %) in Caribbean small states in 2002 to that in 2004?
Offer a very short reply. 0.89. What is the ratio of the Revenue generated (in %) of High income in 2002 to that in 2004?
Your answer should be very brief. 1.94. What is the ratio of the Revenue generated (in %) of Czech Republic in 2002 to that in 2004?
Make the answer very short. 2.81. What is the ratio of the Revenue generated (in %) in United States in 2002 to that in 2004?
Ensure brevity in your answer.  0.92. What is the ratio of the Revenue generated (in %) in Caribbean small states in 2002 to that in 2005?
Offer a terse response. 0.92. What is the ratio of the Revenue generated (in %) in High income in 2002 to that in 2005?
Make the answer very short. 1.99. What is the ratio of the Revenue generated (in %) of United States in 2002 to that in 2005?
Give a very brief answer. 0.96. What is the ratio of the Revenue generated (in %) of Caribbean small states in 2002 to that in 2006?
Offer a terse response. 0.98. What is the ratio of the Revenue generated (in %) of High income in 2002 to that in 2006?
Your answer should be compact. 2.17. What is the ratio of the Revenue generated (in %) in Czech Republic in 2002 to that in 2006?
Ensure brevity in your answer.  2142.51. What is the ratio of the Revenue generated (in %) of United States in 2002 to that in 2006?
Offer a very short reply. 1.01. What is the ratio of the Revenue generated (in %) of Caribbean small states in 2002 to that in 2007?
Make the answer very short. 0.96. What is the ratio of the Revenue generated (in %) in High income in 2002 to that in 2007?
Give a very brief answer. 1.84. What is the ratio of the Revenue generated (in %) in Czech Republic in 2002 to that in 2007?
Make the answer very short. 602.19. What is the ratio of the Revenue generated (in %) in United States in 2002 to that in 2007?
Give a very brief answer. 0.98. What is the ratio of the Revenue generated (in %) in Caribbean small states in 2002 to that in 2008?
Make the answer very short. 1.1. What is the ratio of the Revenue generated (in %) of High income in 2002 to that in 2008?
Your response must be concise. 1.43. What is the ratio of the Revenue generated (in %) of Czech Republic in 2002 to that in 2008?
Your response must be concise. 1908.4. What is the ratio of the Revenue generated (in %) of United States in 2002 to that in 2008?
Offer a terse response. 0.91. What is the ratio of the Revenue generated (in %) in Caribbean small states in 2003 to that in 2004?
Offer a very short reply. 1.04. What is the ratio of the Revenue generated (in %) of High income in 2003 to that in 2004?
Offer a terse response. 1.61. What is the ratio of the Revenue generated (in %) of Czech Republic in 2003 to that in 2004?
Keep it short and to the point. 2.71. What is the ratio of the Revenue generated (in %) of United States in 2003 to that in 2004?
Your response must be concise. 0.99. What is the ratio of the Revenue generated (in %) in Caribbean small states in 2003 to that in 2005?
Your response must be concise. 1.08. What is the ratio of the Revenue generated (in %) of High income in 2003 to that in 2005?
Keep it short and to the point. 1.65. What is the ratio of the Revenue generated (in %) in United States in 2003 to that in 2005?
Keep it short and to the point. 1.03. What is the ratio of the Revenue generated (in %) in Caribbean small states in 2003 to that in 2006?
Ensure brevity in your answer.  1.15. What is the ratio of the Revenue generated (in %) in High income in 2003 to that in 2006?
Your answer should be compact. 1.8. What is the ratio of the Revenue generated (in %) in Czech Republic in 2003 to that in 2006?
Give a very brief answer. 2067.86. What is the ratio of the Revenue generated (in %) of United States in 2003 to that in 2006?
Ensure brevity in your answer.  1.08. What is the ratio of the Revenue generated (in %) in Caribbean small states in 2003 to that in 2007?
Your answer should be very brief. 1.13. What is the ratio of the Revenue generated (in %) in High income in 2003 to that in 2007?
Your answer should be very brief. 1.53. What is the ratio of the Revenue generated (in %) in Czech Republic in 2003 to that in 2007?
Your answer should be very brief. 581.21. What is the ratio of the Revenue generated (in %) of United States in 2003 to that in 2007?
Ensure brevity in your answer.  1.05. What is the ratio of the Revenue generated (in %) in Caribbean small states in 2003 to that in 2008?
Your response must be concise. 1.3. What is the ratio of the Revenue generated (in %) of High income in 2003 to that in 2008?
Your response must be concise. 1.18. What is the ratio of the Revenue generated (in %) of Czech Republic in 2003 to that in 2008?
Provide a succinct answer. 1841.91. What is the ratio of the Revenue generated (in %) in United States in 2003 to that in 2008?
Provide a short and direct response. 0.97. What is the ratio of the Revenue generated (in %) of Caribbean small states in 2004 to that in 2005?
Your response must be concise. 1.03. What is the ratio of the Revenue generated (in %) of High income in 2004 to that in 2005?
Ensure brevity in your answer.  1.03. What is the ratio of the Revenue generated (in %) in United States in 2004 to that in 2005?
Ensure brevity in your answer.  1.04. What is the ratio of the Revenue generated (in %) in Caribbean small states in 2004 to that in 2006?
Ensure brevity in your answer.  1.1. What is the ratio of the Revenue generated (in %) of High income in 2004 to that in 2006?
Provide a succinct answer. 1.12. What is the ratio of the Revenue generated (in %) in Czech Republic in 2004 to that in 2006?
Provide a short and direct response. 763.23. What is the ratio of the Revenue generated (in %) of United States in 2004 to that in 2006?
Provide a short and direct response. 1.09. What is the ratio of the Revenue generated (in %) in Caribbean small states in 2004 to that in 2007?
Provide a succinct answer. 1.08. What is the ratio of the Revenue generated (in %) of High income in 2004 to that in 2007?
Give a very brief answer. 0.95. What is the ratio of the Revenue generated (in %) in Czech Republic in 2004 to that in 2007?
Offer a very short reply. 214.52. What is the ratio of the Revenue generated (in %) in United States in 2004 to that in 2007?
Provide a succinct answer. 1.06. What is the ratio of the Revenue generated (in %) in Caribbean small states in 2004 to that in 2008?
Offer a terse response. 1.24. What is the ratio of the Revenue generated (in %) in High income in 2004 to that in 2008?
Offer a very short reply. 0.74. What is the ratio of the Revenue generated (in %) in Czech Republic in 2004 to that in 2008?
Make the answer very short. 679.83. What is the ratio of the Revenue generated (in %) of United States in 2004 to that in 2008?
Ensure brevity in your answer.  0.98. What is the ratio of the Revenue generated (in %) in Caribbean small states in 2005 to that in 2006?
Your answer should be compact. 1.06. What is the ratio of the Revenue generated (in %) in High income in 2005 to that in 2006?
Your answer should be very brief. 1.09. What is the ratio of the Revenue generated (in %) of United States in 2005 to that in 2006?
Offer a terse response. 1.05. What is the ratio of the Revenue generated (in %) of Caribbean small states in 2005 to that in 2007?
Your response must be concise. 1.05. What is the ratio of the Revenue generated (in %) of High income in 2005 to that in 2007?
Your answer should be compact. 0.93. What is the ratio of the Revenue generated (in %) in United States in 2005 to that in 2007?
Keep it short and to the point. 1.02. What is the ratio of the Revenue generated (in %) in Caribbean small states in 2005 to that in 2008?
Provide a succinct answer. 1.2. What is the ratio of the Revenue generated (in %) of High income in 2005 to that in 2008?
Keep it short and to the point. 0.72. What is the ratio of the Revenue generated (in %) of United States in 2005 to that in 2008?
Offer a very short reply. 0.95. What is the ratio of the Revenue generated (in %) of Caribbean small states in 2006 to that in 2007?
Your response must be concise. 0.99. What is the ratio of the Revenue generated (in %) in High income in 2006 to that in 2007?
Your answer should be very brief. 0.85. What is the ratio of the Revenue generated (in %) of Czech Republic in 2006 to that in 2007?
Your answer should be compact. 0.28. What is the ratio of the Revenue generated (in %) in United States in 2006 to that in 2007?
Make the answer very short. 0.97. What is the ratio of the Revenue generated (in %) of Caribbean small states in 2006 to that in 2008?
Give a very brief answer. 1.13. What is the ratio of the Revenue generated (in %) in High income in 2006 to that in 2008?
Provide a short and direct response. 0.66. What is the ratio of the Revenue generated (in %) in Czech Republic in 2006 to that in 2008?
Keep it short and to the point. 0.89. What is the ratio of the Revenue generated (in %) in United States in 2006 to that in 2008?
Ensure brevity in your answer.  0.9. What is the ratio of the Revenue generated (in %) in Caribbean small states in 2007 to that in 2008?
Keep it short and to the point. 1.15. What is the ratio of the Revenue generated (in %) in High income in 2007 to that in 2008?
Your response must be concise. 0.77. What is the ratio of the Revenue generated (in %) in Czech Republic in 2007 to that in 2008?
Offer a terse response. 3.17. What is the ratio of the Revenue generated (in %) of United States in 2007 to that in 2008?
Provide a short and direct response. 0.93. What is the difference between the highest and the second highest Revenue generated (in %) in Caribbean small states?
Offer a very short reply. 0.3. What is the difference between the highest and the second highest Revenue generated (in %) in High income?
Provide a succinct answer. 0.13. What is the difference between the highest and the second highest Revenue generated (in %) in Czech Republic?
Offer a terse response. 0.08. What is the difference between the highest and the second highest Revenue generated (in %) of United States?
Provide a succinct answer. 0.02. What is the difference between the highest and the lowest Revenue generated (in %) in Caribbean small states?
Your answer should be compact. 1.56. What is the difference between the highest and the lowest Revenue generated (in %) of High income?
Provide a succinct answer. 0.77. What is the difference between the highest and the lowest Revenue generated (in %) of Czech Republic?
Make the answer very short. 1.33. What is the difference between the highest and the lowest Revenue generated (in %) of United States?
Ensure brevity in your answer.  0.15. 